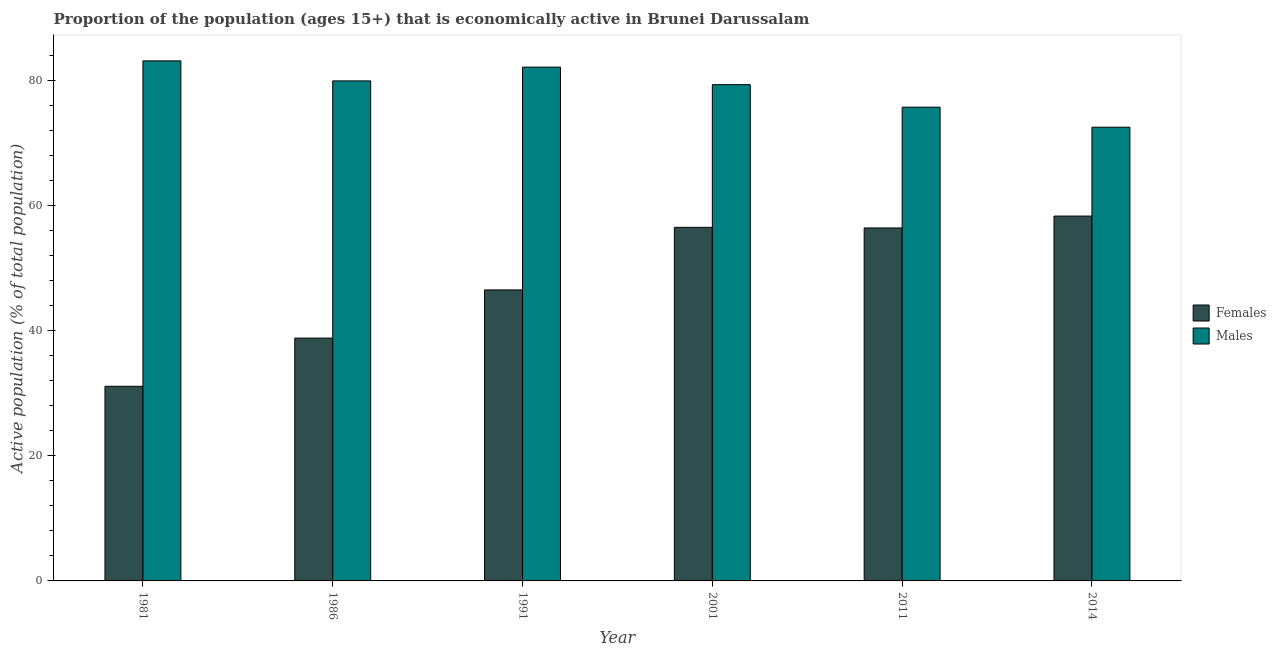How many different coloured bars are there?
Your answer should be compact. 2. How many groups of bars are there?
Give a very brief answer. 6. Are the number of bars per tick equal to the number of legend labels?
Provide a succinct answer. Yes. How many bars are there on the 6th tick from the left?
Offer a very short reply. 2. In how many cases, is the number of bars for a given year not equal to the number of legend labels?
Provide a succinct answer. 0. What is the percentage of economically active male population in 2014?
Provide a short and direct response. 72.5. Across all years, what is the maximum percentage of economically active male population?
Your response must be concise. 83.1. Across all years, what is the minimum percentage of economically active female population?
Your response must be concise. 31.1. In which year was the percentage of economically active male population maximum?
Your answer should be compact. 1981. What is the total percentage of economically active female population in the graph?
Ensure brevity in your answer.  287.6. What is the difference between the percentage of economically active male population in 1981 and that in 1986?
Your answer should be compact. 3.2. What is the difference between the percentage of economically active female population in 2001 and the percentage of economically active male population in 1986?
Make the answer very short. 17.7. What is the average percentage of economically active female population per year?
Keep it short and to the point. 47.93. In the year 2014, what is the difference between the percentage of economically active female population and percentage of economically active male population?
Offer a very short reply. 0. In how many years, is the percentage of economically active female population greater than 8 %?
Offer a very short reply. 6. What is the ratio of the percentage of economically active female population in 1981 to that in 2014?
Your answer should be compact. 0.53. Is the percentage of economically active male population in 1981 less than that in 2011?
Offer a very short reply. No. Is the difference between the percentage of economically active female population in 1981 and 1991 greater than the difference between the percentage of economically active male population in 1981 and 1991?
Offer a terse response. No. What is the difference between the highest and the second highest percentage of economically active female population?
Your answer should be compact. 1.8. What is the difference between the highest and the lowest percentage of economically active male population?
Provide a succinct answer. 10.6. In how many years, is the percentage of economically active male population greater than the average percentage of economically active male population taken over all years?
Provide a succinct answer. 4. What does the 1st bar from the left in 1981 represents?
Offer a terse response. Females. What does the 1st bar from the right in 2014 represents?
Provide a short and direct response. Males. Are all the bars in the graph horizontal?
Your answer should be compact. No. How many years are there in the graph?
Your answer should be very brief. 6. What is the difference between two consecutive major ticks on the Y-axis?
Provide a short and direct response. 20. Does the graph contain any zero values?
Provide a succinct answer. No. Where does the legend appear in the graph?
Your answer should be compact. Center right. How many legend labels are there?
Make the answer very short. 2. What is the title of the graph?
Your answer should be very brief. Proportion of the population (ages 15+) that is economically active in Brunei Darussalam. What is the label or title of the Y-axis?
Give a very brief answer. Active population (% of total population). What is the Active population (% of total population) of Females in 1981?
Make the answer very short. 31.1. What is the Active population (% of total population) in Males in 1981?
Your answer should be very brief. 83.1. What is the Active population (% of total population) in Females in 1986?
Give a very brief answer. 38.8. What is the Active population (% of total population) in Males in 1986?
Make the answer very short. 79.9. What is the Active population (% of total population) of Females in 1991?
Keep it short and to the point. 46.5. What is the Active population (% of total population) in Males in 1991?
Your answer should be very brief. 82.1. What is the Active population (% of total population) in Females in 2001?
Provide a short and direct response. 56.5. What is the Active population (% of total population) of Males in 2001?
Provide a short and direct response. 79.3. What is the Active population (% of total population) in Females in 2011?
Give a very brief answer. 56.4. What is the Active population (% of total population) of Males in 2011?
Offer a terse response. 75.7. What is the Active population (% of total population) of Females in 2014?
Offer a very short reply. 58.3. What is the Active population (% of total population) in Males in 2014?
Give a very brief answer. 72.5. Across all years, what is the maximum Active population (% of total population) of Females?
Provide a short and direct response. 58.3. Across all years, what is the maximum Active population (% of total population) in Males?
Ensure brevity in your answer.  83.1. Across all years, what is the minimum Active population (% of total population) in Females?
Ensure brevity in your answer.  31.1. Across all years, what is the minimum Active population (% of total population) in Males?
Provide a short and direct response. 72.5. What is the total Active population (% of total population) in Females in the graph?
Keep it short and to the point. 287.6. What is the total Active population (% of total population) in Males in the graph?
Give a very brief answer. 472.6. What is the difference between the Active population (% of total population) in Females in 1981 and that in 1991?
Provide a succinct answer. -15.4. What is the difference between the Active population (% of total population) of Males in 1981 and that in 1991?
Give a very brief answer. 1. What is the difference between the Active population (% of total population) in Females in 1981 and that in 2001?
Keep it short and to the point. -25.4. What is the difference between the Active population (% of total population) in Females in 1981 and that in 2011?
Offer a very short reply. -25.3. What is the difference between the Active population (% of total population) of Males in 1981 and that in 2011?
Give a very brief answer. 7.4. What is the difference between the Active population (% of total population) in Females in 1981 and that in 2014?
Your answer should be compact. -27.2. What is the difference between the Active population (% of total population) of Females in 1986 and that in 1991?
Your answer should be compact. -7.7. What is the difference between the Active population (% of total population) in Females in 1986 and that in 2001?
Give a very brief answer. -17.7. What is the difference between the Active population (% of total population) of Females in 1986 and that in 2011?
Ensure brevity in your answer.  -17.6. What is the difference between the Active population (% of total population) of Females in 1986 and that in 2014?
Offer a terse response. -19.5. What is the difference between the Active population (% of total population) in Females in 1991 and that in 2011?
Give a very brief answer. -9.9. What is the difference between the Active population (% of total population) of Males in 1991 and that in 2011?
Offer a terse response. 6.4. What is the difference between the Active population (% of total population) in Males in 2001 and that in 2011?
Give a very brief answer. 3.6. What is the difference between the Active population (% of total population) in Males in 2001 and that in 2014?
Offer a very short reply. 6.8. What is the difference between the Active population (% of total population) of Males in 2011 and that in 2014?
Your answer should be very brief. 3.2. What is the difference between the Active population (% of total population) of Females in 1981 and the Active population (% of total population) of Males in 1986?
Make the answer very short. -48.8. What is the difference between the Active population (% of total population) in Females in 1981 and the Active population (% of total population) in Males in 1991?
Your answer should be compact. -51. What is the difference between the Active population (% of total population) in Females in 1981 and the Active population (% of total population) in Males in 2001?
Your answer should be very brief. -48.2. What is the difference between the Active population (% of total population) in Females in 1981 and the Active population (% of total population) in Males in 2011?
Provide a short and direct response. -44.6. What is the difference between the Active population (% of total population) in Females in 1981 and the Active population (% of total population) in Males in 2014?
Give a very brief answer. -41.4. What is the difference between the Active population (% of total population) in Females in 1986 and the Active population (% of total population) in Males in 1991?
Provide a succinct answer. -43.3. What is the difference between the Active population (% of total population) in Females in 1986 and the Active population (% of total population) in Males in 2001?
Your response must be concise. -40.5. What is the difference between the Active population (% of total population) of Females in 1986 and the Active population (% of total population) of Males in 2011?
Keep it short and to the point. -36.9. What is the difference between the Active population (% of total population) in Females in 1986 and the Active population (% of total population) in Males in 2014?
Offer a very short reply. -33.7. What is the difference between the Active population (% of total population) in Females in 1991 and the Active population (% of total population) in Males in 2001?
Provide a succinct answer. -32.8. What is the difference between the Active population (% of total population) of Females in 1991 and the Active population (% of total population) of Males in 2011?
Your answer should be compact. -29.2. What is the difference between the Active population (% of total population) of Females in 2001 and the Active population (% of total population) of Males in 2011?
Provide a succinct answer. -19.2. What is the difference between the Active population (% of total population) of Females in 2011 and the Active population (% of total population) of Males in 2014?
Provide a short and direct response. -16.1. What is the average Active population (% of total population) in Females per year?
Ensure brevity in your answer.  47.93. What is the average Active population (% of total population) in Males per year?
Your response must be concise. 78.77. In the year 1981, what is the difference between the Active population (% of total population) in Females and Active population (% of total population) in Males?
Your response must be concise. -52. In the year 1986, what is the difference between the Active population (% of total population) in Females and Active population (% of total population) in Males?
Keep it short and to the point. -41.1. In the year 1991, what is the difference between the Active population (% of total population) in Females and Active population (% of total population) in Males?
Your response must be concise. -35.6. In the year 2001, what is the difference between the Active population (% of total population) of Females and Active population (% of total population) of Males?
Provide a succinct answer. -22.8. In the year 2011, what is the difference between the Active population (% of total population) of Females and Active population (% of total population) of Males?
Offer a terse response. -19.3. In the year 2014, what is the difference between the Active population (% of total population) in Females and Active population (% of total population) in Males?
Make the answer very short. -14.2. What is the ratio of the Active population (% of total population) in Females in 1981 to that in 1986?
Keep it short and to the point. 0.8. What is the ratio of the Active population (% of total population) of Males in 1981 to that in 1986?
Provide a succinct answer. 1.04. What is the ratio of the Active population (% of total population) in Females in 1981 to that in 1991?
Your answer should be very brief. 0.67. What is the ratio of the Active population (% of total population) of Males in 1981 to that in 1991?
Offer a very short reply. 1.01. What is the ratio of the Active population (% of total population) of Females in 1981 to that in 2001?
Your answer should be compact. 0.55. What is the ratio of the Active population (% of total population) in Males in 1981 to that in 2001?
Ensure brevity in your answer.  1.05. What is the ratio of the Active population (% of total population) of Females in 1981 to that in 2011?
Make the answer very short. 0.55. What is the ratio of the Active population (% of total population) of Males in 1981 to that in 2011?
Make the answer very short. 1.1. What is the ratio of the Active population (% of total population) in Females in 1981 to that in 2014?
Offer a terse response. 0.53. What is the ratio of the Active population (% of total population) of Males in 1981 to that in 2014?
Your answer should be very brief. 1.15. What is the ratio of the Active population (% of total population) in Females in 1986 to that in 1991?
Provide a short and direct response. 0.83. What is the ratio of the Active population (% of total population) of Males in 1986 to that in 1991?
Give a very brief answer. 0.97. What is the ratio of the Active population (% of total population) of Females in 1986 to that in 2001?
Give a very brief answer. 0.69. What is the ratio of the Active population (% of total population) of Males in 1986 to that in 2001?
Ensure brevity in your answer.  1.01. What is the ratio of the Active population (% of total population) of Females in 1986 to that in 2011?
Provide a succinct answer. 0.69. What is the ratio of the Active population (% of total population) in Males in 1986 to that in 2011?
Keep it short and to the point. 1.06. What is the ratio of the Active population (% of total population) in Females in 1986 to that in 2014?
Your answer should be very brief. 0.67. What is the ratio of the Active population (% of total population) in Males in 1986 to that in 2014?
Provide a succinct answer. 1.1. What is the ratio of the Active population (% of total population) in Females in 1991 to that in 2001?
Give a very brief answer. 0.82. What is the ratio of the Active population (% of total population) in Males in 1991 to that in 2001?
Provide a succinct answer. 1.04. What is the ratio of the Active population (% of total population) in Females in 1991 to that in 2011?
Your response must be concise. 0.82. What is the ratio of the Active population (% of total population) in Males in 1991 to that in 2011?
Make the answer very short. 1.08. What is the ratio of the Active population (% of total population) in Females in 1991 to that in 2014?
Your answer should be very brief. 0.8. What is the ratio of the Active population (% of total population) of Males in 1991 to that in 2014?
Keep it short and to the point. 1.13. What is the ratio of the Active population (% of total population) of Males in 2001 to that in 2011?
Make the answer very short. 1.05. What is the ratio of the Active population (% of total population) of Females in 2001 to that in 2014?
Your response must be concise. 0.97. What is the ratio of the Active population (% of total population) of Males in 2001 to that in 2014?
Offer a terse response. 1.09. What is the ratio of the Active population (% of total population) of Females in 2011 to that in 2014?
Offer a very short reply. 0.97. What is the ratio of the Active population (% of total population) in Males in 2011 to that in 2014?
Offer a very short reply. 1.04. What is the difference between the highest and the lowest Active population (% of total population) in Females?
Provide a short and direct response. 27.2. What is the difference between the highest and the lowest Active population (% of total population) in Males?
Offer a very short reply. 10.6. 